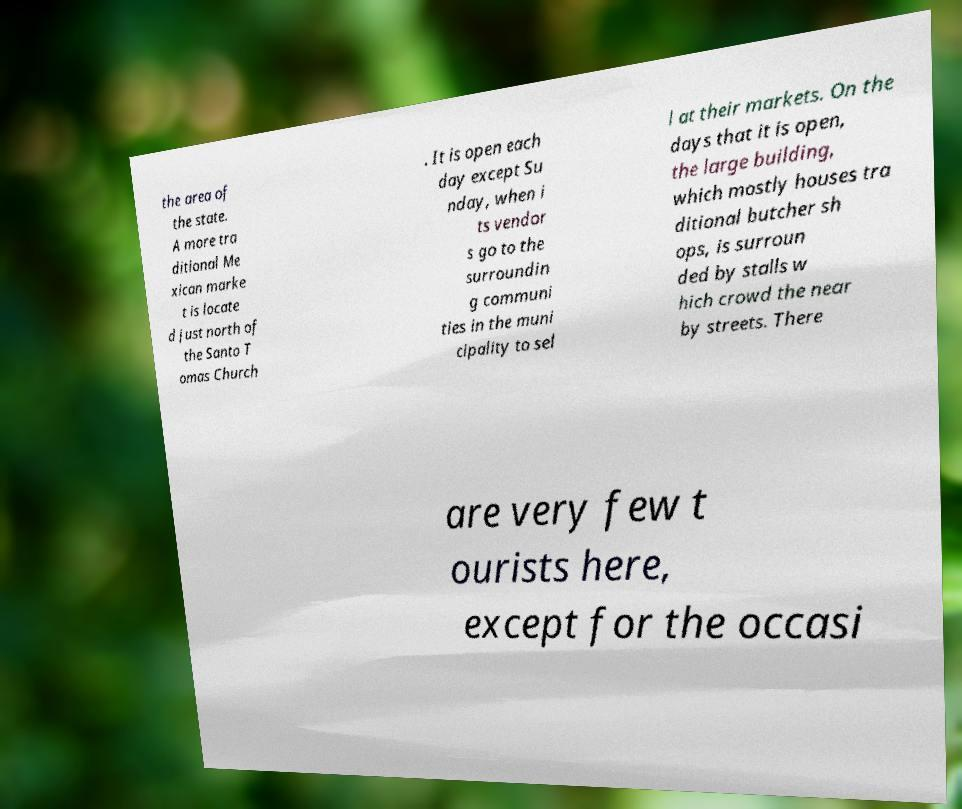Please identify and transcribe the text found in this image. the area of the state. A more tra ditional Me xican marke t is locate d just north of the Santo T omas Church . It is open each day except Su nday, when i ts vendor s go to the surroundin g communi ties in the muni cipality to sel l at their markets. On the days that it is open, the large building, which mostly houses tra ditional butcher sh ops, is surroun ded by stalls w hich crowd the near by streets. There are very few t ourists here, except for the occasi 